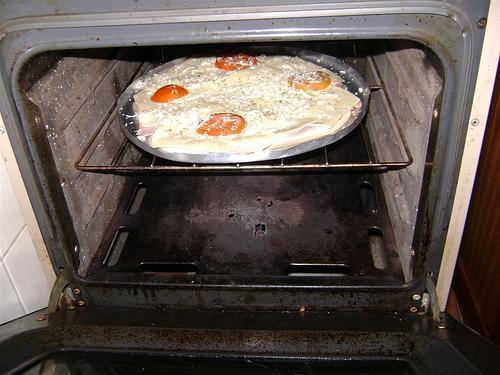Is the caption "The pizza is out of the oven." a true representation of the image?
Answer yes or no. No. 